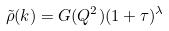<formula> <loc_0><loc_0><loc_500><loc_500>\tilde { \rho } ( k ) = G ( Q ^ { 2 } ) ( 1 + \tau ) ^ { \lambda }</formula> 